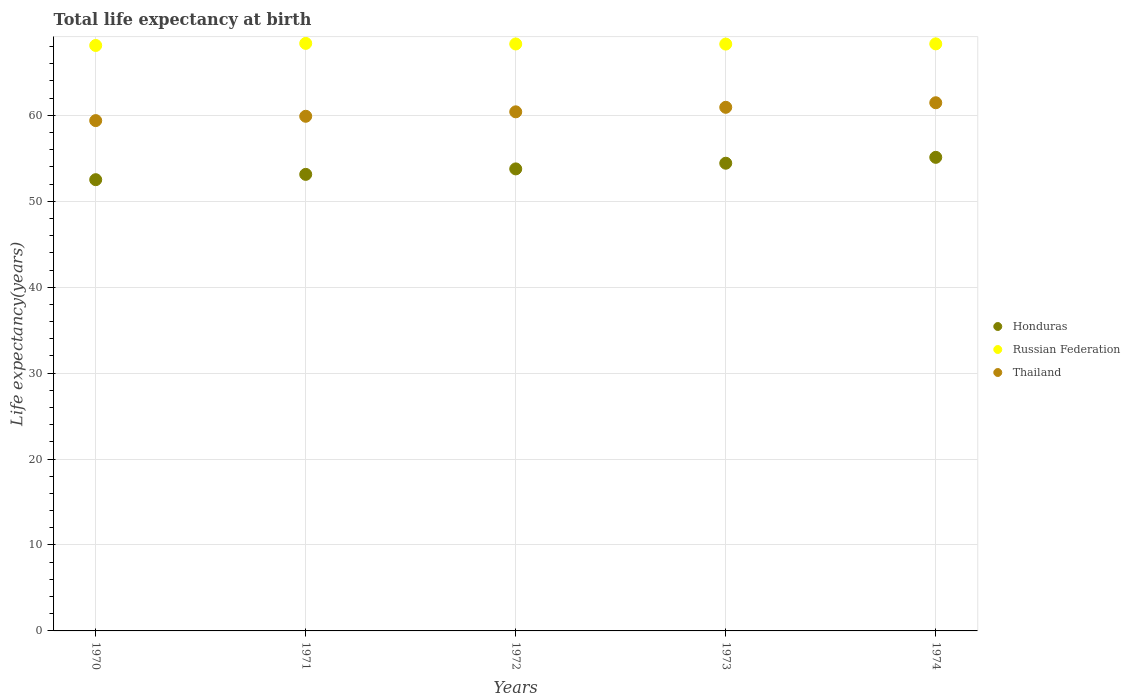What is the life expectancy at birth in in Russian Federation in 1970?
Your response must be concise. 68.13. Across all years, what is the maximum life expectancy at birth in in Russian Federation?
Your answer should be compact. 68.38. Across all years, what is the minimum life expectancy at birth in in Russian Federation?
Keep it short and to the point. 68.13. In which year was the life expectancy at birth in in Honduras maximum?
Make the answer very short. 1974. What is the total life expectancy at birth in in Thailand in the graph?
Make the answer very short. 302.1. What is the difference between the life expectancy at birth in in Honduras in 1972 and that in 1973?
Offer a terse response. -0.66. What is the difference between the life expectancy at birth in in Thailand in 1973 and the life expectancy at birth in in Russian Federation in 1970?
Keep it short and to the point. -7.2. What is the average life expectancy at birth in in Honduras per year?
Offer a very short reply. 53.79. In the year 1970, what is the difference between the life expectancy at birth in in Russian Federation and life expectancy at birth in in Honduras?
Your response must be concise. 15.62. What is the ratio of the life expectancy at birth in in Thailand in 1973 to that in 1974?
Offer a very short reply. 0.99. Is the life expectancy at birth in in Thailand in 1972 less than that in 1974?
Offer a terse response. Yes. Is the difference between the life expectancy at birth in in Russian Federation in 1971 and 1973 greater than the difference between the life expectancy at birth in in Honduras in 1971 and 1973?
Offer a terse response. Yes. What is the difference between the highest and the second highest life expectancy at birth in in Russian Federation?
Give a very brief answer. 0.06. What is the difference between the highest and the lowest life expectancy at birth in in Thailand?
Give a very brief answer. 2.08. In how many years, is the life expectancy at birth in in Thailand greater than the average life expectancy at birth in in Thailand taken over all years?
Give a very brief answer. 2. Is the sum of the life expectancy at birth in in Russian Federation in 1971 and 1974 greater than the maximum life expectancy at birth in in Honduras across all years?
Offer a terse response. Yes. Does the life expectancy at birth in in Russian Federation monotonically increase over the years?
Your answer should be very brief. No. Is the life expectancy at birth in in Honduras strictly greater than the life expectancy at birth in in Thailand over the years?
Offer a terse response. No. Is the life expectancy at birth in in Honduras strictly less than the life expectancy at birth in in Thailand over the years?
Your answer should be compact. Yes. How many years are there in the graph?
Ensure brevity in your answer.  5. Does the graph contain any zero values?
Ensure brevity in your answer.  No. Does the graph contain grids?
Your answer should be very brief. Yes. Where does the legend appear in the graph?
Give a very brief answer. Center right. How many legend labels are there?
Offer a terse response. 3. How are the legend labels stacked?
Provide a succinct answer. Vertical. What is the title of the graph?
Offer a very short reply. Total life expectancy at birth. Does "Mongolia" appear as one of the legend labels in the graph?
Your answer should be very brief. No. What is the label or title of the Y-axis?
Provide a short and direct response. Life expectancy(years). What is the Life expectancy(years) in Honduras in 1970?
Ensure brevity in your answer.  52.52. What is the Life expectancy(years) of Russian Federation in 1970?
Your answer should be compact. 68.13. What is the Life expectancy(years) in Thailand in 1970?
Make the answer very short. 59.39. What is the Life expectancy(years) of Honduras in 1971?
Make the answer very short. 53.13. What is the Life expectancy(years) in Russian Federation in 1971?
Your answer should be very brief. 68.38. What is the Life expectancy(years) of Thailand in 1971?
Keep it short and to the point. 59.89. What is the Life expectancy(years) of Honduras in 1972?
Your answer should be very brief. 53.77. What is the Life expectancy(years) of Russian Federation in 1972?
Keep it short and to the point. 68.31. What is the Life expectancy(years) of Thailand in 1972?
Offer a very short reply. 60.41. What is the Life expectancy(years) of Honduras in 1973?
Give a very brief answer. 54.43. What is the Life expectancy(years) of Russian Federation in 1973?
Offer a very short reply. 68.29. What is the Life expectancy(years) of Thailand in 1973?
Give a very brief answer. 60.94. What is the Life expectancy(years) of Honduras in 1974?
Make the answer very short. 55.12. What is the Life expectancy(years) in Russian Federation in 1974?
Provide a short and direct response. 68.32. What is the Life expectancy(years) of Thailand in 1974?
Make the answer very short. 61.47. Across all years, what is the maximum Life expectancy(years) in Honduras?
Your response must be concise. 55.12. Across all years, what is the maximum Life expectancy(years) in Russian Federation?
Your answer should be compact. 68.38. Across all years, what is the maximum Life expectancy(years) of Thailand?
Ensure brevity in your answer.  61.47. Across all years, what is the minimum Life expectancy(years) in Honduras?
Your response must be concise. 52.52. Across all years, what is the minimum Life expectancy(years) in Russian Federation?
Ensure brevity in your answer.  68.13. Across all years, what is the minimum Life expectancy(years) in Thailand?
Your answer should be compact. 59.39. What is the total Life expectancy(years) in Honduras in the graph?
Provide a short and direct response. 268.96. What is the total Life expectancy(years) of Russian Federation in the graph?
Make the answer very short. 341.43. What is the total Life expectancy(years) in Thailand in the graph?
Make the answer very short. 302.1. What is the difference between the Life expectancy(years) of Honduras in 1970 and that in 1971?
Make the answer very short. -0.62. What is the difference between the Life expectancy(years) in Russian Federation in 1970 and that in 1971?
Offer a very short reply. -0.24. What is the difference between the Life expectancy(years) in Thailand in 1970 and that in 1971?
Your answer should be very brief. -0.5. What is the difference between the Life expectancy(years) of Honduras in 1970 and that in 1972?
Offer a very short reply. -1.26. What is the difference between the Life expectancy(years) of Russian Federation in 1970 and that in 1972?
Give a very brief answer. -0.17. What is the difference between the Life expectancy(years) of Thailand in 1970 and that in 1972?
Ensure brevity in your answer.  -1.02. What is the difference between the Life expectancy(years) of Honduras in 1970 and that in 1973?
Give a very brief answer. -1.92. What is the difference between the Life expectancy(years) in Russian Federation in 1970 and that in 1973?
Provide a succinct answer. -0.16. What is the difference between the Life expectancy(years) in Thailand in 1970 and that in 1973?
Offer a very short reply. -1.55. What is the difference between the Life expectancy(years) of Honduras in 1970 and that in 1974?
Keep it short and to the point. -2.6. What is the difference between the Life expectancy(years) in Russian Federation in 1970 and that in 1974?
Give a very brief answer. -0.19. What is the difference between the Life expectancy(years) of Thailand in 1970 and that in 1974?
Offer a very short reply. -2.08. What is the difference between the Life expectancy(years) of Honduras in 1971 and that in 1972?
Offer a very short reply. -0.64. What is the difference between the Life expectancy(years) in Russian Federation in 1971 and that in 1972?
Offer a very short reply. 0.07. What is the difference between the Life expectancy(years) of Thailand in 1971 and that in 1972?
Provide a short and direct response. -0.52. What is the difference between the Life expectancy(years) in Honduras in 1971 and that in 1973?
Your response must be concise. -1.3. What is the difference between the Life expectancy(years) in Russian Federation in 1971 and that in 1973?
Provide a succinct answer. 0.08. What is the difference between the Life expectancy(years) in Thailand in 1971 and that in 1973?
Provide a short and direct response. -1.04. What is the difference between the Life expectancy(years) of Honduras in 1971 and that in 1974?
Ensure brevity in your answer.  -1.98. What is the difference between the Life expectancy(years) in Russian Federation in 1971 and that in 1974?
Keep it short and to the point. 0.06. What is the difference between the Life expectancy(years) of Thailand in 1971 and that in 1974?
Ensure brevity in your answer.  -1.57. What is the difference between the Life expectancy(years) of Honduras in 1972 and that in 1973?
Ensure brevity in your answer.  -0.66. What is the difference between the Life expectancy(years) in Russian Federation in 1972 and that in 1973?
Your response must be concise. 0.01. What is the difference between the Life expectancy(years) in Thailand in 1972 and that in 1973?
Offer a terse response. -0.53. What is the difference between the Life expectancy(years) of Honduras in 1972 and that in 1974?
Keep it short and to the point. -1.34. What is the difference between the Life expectancy(years) in Russian Federation in 1972 and that in 1974?
Make the answer very short. -0.01. What is the difference between the Life expectancy(years) of Thailand in 1972 and that in 1974?
Your answer should be very brief. -1.06. What is the difference between the Life expectancy(years) of Honduras in 1973 and that in 1974?
Offer a very short reply. -0.68. What is the difference between the Life expectancy(years) of Russian Federation in 1973 and that in 1974?
Provide a short and direct response. -0.03. What is the difference between the Life expectancy(years) of Thailand in 1973 and that in 1974?
Your answer should be compact. -0.53. What is the difference between the Life expectancy(years) in Honduras in 1970 and the Life expectancy(years) in Russian Federation in 1971?
Provide a succinct answer. -15.86. What is the difference between the Life expectancy(years) in Honduras in 1970 and the Life expectancy(years) in Thailand in 1971?
Offer a very short reply. -7.38. What is the difference between the Life expectancy(years) of Russian Federation in 1970 and the Life expectancy(years) of Thailand in 1971?
Offer a terse response. 8.24. What is the difference between the Life expectancy(years) of Honduras in 1970 and the Life expectancy(years) of Russian Federation in 1972?
Offer a terse response. -15.79. What is the difference between the Life expectancy(years) of Honduras in 1970 and the Life expectancy(years) of Thailand in 1972?
Make the answer very short. -7.9. What is the difference between the Life expectancy(years) in Russian Federation in 1970 and the Life expectancy(years) in Thailand in 1972?
Give a very brief answer. 7.72. What is the difference between the Life expectancy(years) of Honduras in 1970 and the Life expectancy(years) of Russian Federation in 1973?
Your answer should be very brief. -15.78. What is the difference between the Life expectancy(years) of Honduras in 1970 and the Life expectancy(years) of Thailand in 1973?
Give a very brief answer. -8.42. What is the difference between the Life expectancy(years) of Russian Federation in 1970 and the Life expectancy(years) of Thailand in 1973?
Offer a terse response. 7.2. What is the difference between the Life expectancy(years) in Honduras in 1970 and the Life expectancy(years) in Russian Federation in 1974?
Provide a succinct answer. -15.81. What is the difference between the Life expectancy(years) in Honduras in 1970 and the Life expectancy(years) in Thailand in 1974?
Provide a succinct answer. -8.95. What is the difference between the Life expectancy(years) of Russian Federation in 1970 and the Life expectancy(years) of Thailand in 1974?
Offer a very short reply. 6.67. What is the difference between the Life expectancy(years) of Honduras in 1971 and the Life expectancy(years) of Russian Federation in 1972?
Provide a succinct answer. -15.18. What is the difference between the Life expectancy(years) of Honduras in 1971 and the Life expectancy(years) of Thailand in 1972?
Offer a very short reply. -7.28. What is the difference between the Life expectancy(years) of Russian Federation in 1971 and the Life expectancy(years) of Thailand in 1972?
Your answer should be compact. 7.96. What is the difference between the Life expectancy(years) of Honduras in 1971 and the Life expectancy(years) of Russian Federation in 1973?
Make the answer very short. -15.16. What is the difference between the Life expectancy(years) in Honduras in 1971 and the Life expectancy(years) in Thailand in 1973?
Provide a short and direct response. -7.81. What is the difference between the Life expectancy(years) of Russian Federation in 1971 and the Life expectancy(years) of Thailand in 1973?
Ensure brevity in your answer.  7.44. What is the difference between the Life expectancy(years) in Honduras in 1971 and the Life expectancy(years) in Russian Federation in 1974?
Provide a succinct answer. -15.19. What is the difference between the Life expectancy(years) in Honduras in 1971 and the Life expectancy(years) in Thailand in 1974?
Your answer should be very brief. -8.34. What is the difference between the Life expectancy(years) of Russian Federation in 1971 and the Life expectancy(years) of Thailand in 1974?
Your answer should be very brief. 6.91. What is the difference between the Life expectancy(years) in Honduras in 1972 and the Life expectancy(years) in Russian Federation in 1973?
Your answer should be compact. -14.52. What is the difference between the Life expectancy(years) of Honduras in 1972 and the Life expectancy(years) of Thailand in 1973?
Provide a short and direct response. -7.17. What is the difference between the Life expectancy(years) in Russian Federation in 1972 and the Life expectancy(years) in Thailand in 1973?
Keep it short and to the point. 7.37. What is the difference between the Life expectancy(years) in Honduras in 1972 and the Life expectancy(years) in Russian Federation in 1974?
Your answer should be compact. -14.55. What is the difference between the Life expectancy(years) in Honduras in 1972 and the Life expectancy(years) in Thailand in 1974?
Your answer should be very brief. -7.7. What is the difference between the Life expectancy(years) of Russian Federation in 1972 and the Life expectancy(years) of Thailand in 1974?
Provide a short and direct response. 6.84. What is the difference between the Life expectancy(years) of Honduras in 1973 and the Life expectancy(years) of Russian Federation in 1974?
Ensure brevity in your answer.  -13.89. What is the difference between the Life expectancy(years) in Honduras in 1973 and the Life expectancy(years) in Thailand in 1974?
Provide a short and direct response. -7.04. What is the difference between the Life expectancy(years) of Russian Federation in 1973 and the Life expectancy(years) of Thailand in 1974?
Your response must be concise. 6.83. What is the average Life expectancy(years) in Honduras per year?
Keep it short and to the point. 53.79. What is the average Life expectancy(years) in Russian Federation per year?
Your response must be concise. 68.29. What is the average Life expectancy(years) of Thailand per year?
Provide a succinct answer. 60.42. In the year 1970, what is the difference between the Life expectancy(years) in Honduras and Life expectancy(years) in Russian Federation?
Make the answer very short. -15.62. In the year 1970, what is the difference between the Life expectancy(years) in Honduras and Life expectancy(years) in Thailand?
Your response must be concise. -6.88. In the year 1970, what is the difference between the Life expectancy(years) in Russian Federation and Life expectancy(years) in Thailand?
Keep it short and to the point. 8.74. In the year 1971, what is the difference between the Life expectancy(years) in Honduras and Life expectancy(years) in Russian Federation?
Offer a terse response. -15.24. In the year 1971, what is the difference between the Life expectancy(years) of Honduras and Life expectancy(years) of Thailand?
Provide a short and direct response. -6.76. In the year 1971, what is the difference between the Life expectancy(years) in Russian Federation and Life expectancy(years) in Thailand?
Provide a succinct answer. 8.48. In the year 1972, what is the difference between the Life expectancy(years) in Honduras and Life expectancy(years) in Russian Federation?
Your answer should be very brief. -14.54. In the year 1972, what is the difference between the Life expectancy(years) of Honduras and Life expectancy(years) of Thailand?
Keep it short and to the point. -6.64. In the year 1972, what is the difference between the Life expectancy(years) of Russian Federation and Life expectancy(years) of Thailand?
Give a very brief answer. 7.9. In the year 1973, what is the difference between the Life expectancy(years) of Honduras and Life expectancy(years) of Russian Federation?
Give a very brief answer. -13.86. In the year 1973, what is the difference between the Life expectancy(years) in Honduras and Life expectancy(years) in Thailand?
Provide a short and direct response. -6.51. In the year 1973, what is the difference between the Life expectancy(years) in Russian Federation and Life expectancy(years) in Thailand?
Give a very brief answer. 7.36. In the year 1974, what is the difference between the Life expectancy(years) of Honduras and Life expectancy(years) of Russian Federation?
Offer a terse response. -13.21. In the year 1974, what is the difference between the Life expectancy(years) of Honduras and Life expectancy(years) of Thailand?
Keep it short and to the point. -6.35. In the year 1974, what is the difference between the Life expectancy(years) of Russian Federation and Life expectancy(years) of Thailand?
Keep it short and to the point. 6.85. What is the ratio of the Life expectancy(years) in Honduras in 1970 to that in 1971?
Provide a succinct answer. 0.99. What is the ratio of the Life expectancy(years) in Russian Federation in 1970 to that in 1971?
Your answer should be compact. 1. What is the ratio of the Life expectancy(years) in Thailand in 1970 to that in 1971?
Your response must be concise. 0.99. What is the ratio of the Life expectancy(years) in Honduras in 1970 to that in 1972?
Keep it short and to the point. 0.98. What is the ratio of the Life expectancy(years) of Russian Federation in 1970 to that in 1972?
Keep it short and to the point. 1. What is the ratio of the Life expectancy(years) of Thailand in 1970 to that in 1972?
Provide a short and direct response. 0.98. What is the ratio of the Life expectancy(years) of Honduras in 1970 to that in 1973?
Offer a very short reply. 0.96. What is the ratio of the Life expectancy(years) of Russian Federation in 1970 to that in 1973?
Offer a very short reply. 1. What is the ratio of the Life expectancy(years) of Thailand in 1970 to that in 1973?
Give a very brief answer. 0.97. What is the ratio of the Life expectancy(years) of Honduras in 1970 to that in 1974?
Offer a very short reply. 0.95. What is the ratio of the Life expectancy(years) in Thailand in 1970 to that in 1974?
Offer a very short reply. 0.97. What is the ratio of the Life expectancy(years) in Honduras in 1971 to that in 1972?
Provide a short and direct response. 0.99. What is the ratio of the Life expectancy(years) of Russian Federation in 1971 to that in 1972?
Keep it short and to the point. 1. What is the ratio of the Life expectancy(years) of Honduras in 1971 to that in 1973?
Make the answer very short. 0.98. What is the ratio of the Life expectancy(years) of Russian Federation in 1971 to that in 1973?
Give a very brief answer. 1. What is the ratio of the Life expectancy(years) of Thailand in 1971 to that in 1973?
Make the answer very short. 0.98. What is the ratio of the Life expectancy(years) in Russian Federation in 1971 to that in 1974?
Offer a terse response. 1. What is the ratio of the Life expectancy(years) of Thailand in 1971 to that in 1974?
Keep it short and to the point. 0.97. What is the ratio of the Life expectancy(years) in Honduras in 1972 to that in 1973?
Ensure brevity in your answer.  0.99. What is the ratio of the Life expectancy(years) of Russian Federation in 1972 to that in 1973?
Provide a succinct answer. 1. What is the ratio of the Life expectancy(years) in Thailand in 1972 to that in 1973?
Your answer should be compact. 0.99. What is the ratio of the Life expectancy(years) in Honduras in 1972 to that in 1974?
Your answer should be compact. 0.98. What is the ratio of the Life expectancy(years) of Thailand in 1972 to that in 1974?
Keep it short and to the point. 0.98. What is the ratio of the Life expectancy(years) of Honduras in 1973 to that in 1974?
Give a very brief answer. 0.99. What is the difference between the highest and the second highest Life expectancy(years) in Honduras?
Offer a very short reply. 0.68. What is the difference between the highest and the second highest Life expectancy(years) of Russian Federation?
Provide a short and direct response. 0.06. What is the difference between the highest and the second highest Life expectancy(years) in Thailand?
Offer a very short reply. 0.53. What is the difference between the highest and the lowest Life expectancy(years) in Honduras?
Your answer should be compact. 2.6. What is the difference between the highest and the lowest Life expectancy(years) in Russian Federation?
Give a very brief answer. 0.24. What is the difference between the highest and the lowest Life expectancy(years) in Thailand?
Provide a short and direct response. 2.08. 